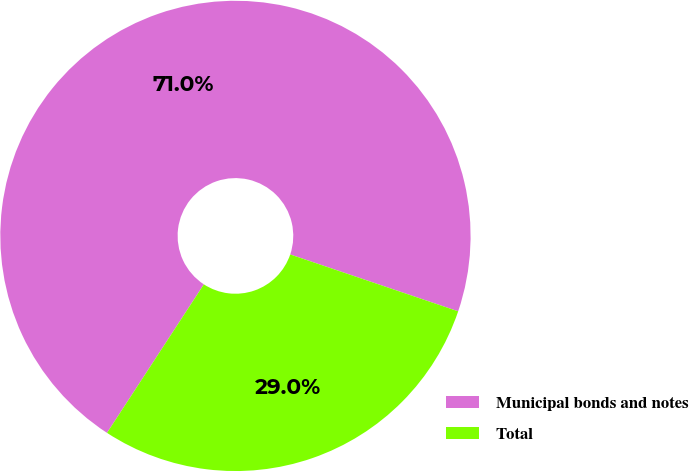<chart> <loc_0><loc_0><loc_500><loc_500><pie_chart><fcel>Municipal bonds and notes<fcel>Total<nl><fcel>71.0%<fcel>29.0%<nl></chart> 